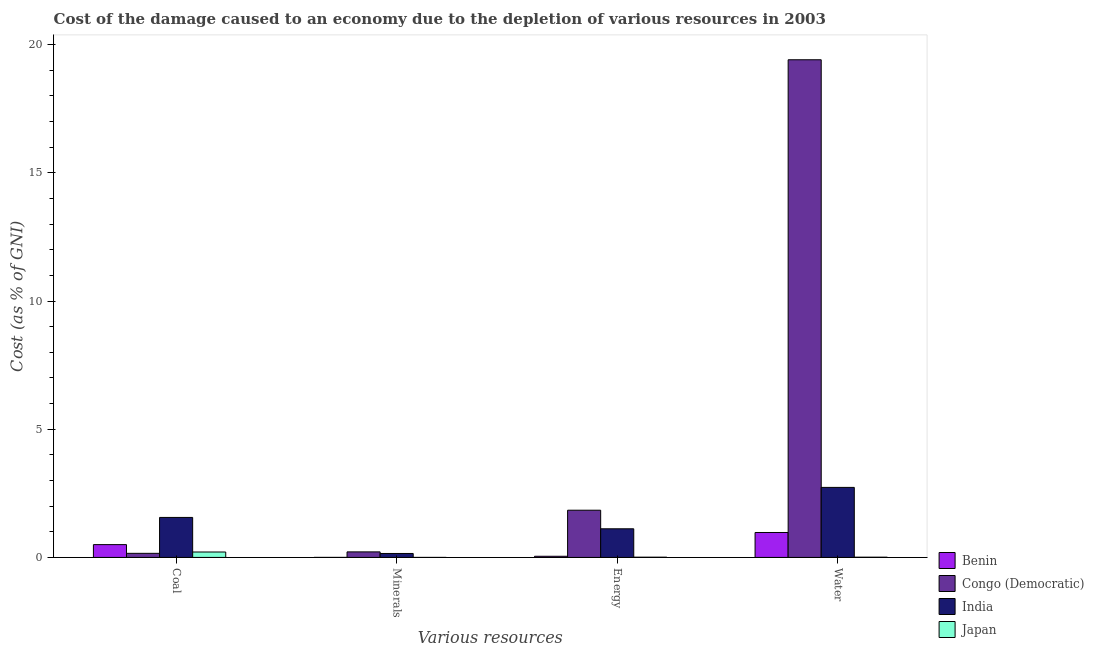How many groups of bars are there?
Ensure brevity in your answer.  4. Are the number of bars per tick equal to the number of legend labels?
Make the answer very short. Yes. Are the number of bars on each tick of the X-axis equal?
Ensure brevity in your answer.  Yes. What is the label of the 3rd group of bars from the left?
Provide a succinct answer. Energy. What is the cost of damage due to depletion of water in India?
Give a very brief answer. 2.73. Across all countries, what is the maximum cost of damage due to depletion of water?
Your answer should be compact. 19.41. Across all countries, what is the minimum cost of damage due to depletion of coal?
Make the answer very short. 0.16. In which country was the cost of damage due to depletion of minerals minimum?
Your response must be concise. Japan. What is the total cost of damage due to depletion of minerals in the graph?
Offer a very short reply. 0.37. What is the difference between the cost of damage due to depletion of coal in Benin and that in Japan?
Offer a very short reply. 0.29. What is the difference between the cost of damage due to depletion of minerals in Benin and the cost of damage due to depletion of water in Congo (Democratic)?
Make the answer very short. -19.41. What is the average cost of damage due to depletion of minerals per country?
Your response must be concise. 0.09. What is the difference between the cost of damage due to depletion of coal and cost of damage due to depletion of energy in Japan?
Keep it short and to the point. 0.2. What is the ratio of the cost of damage due to depletion of coal in India to that in Japan?
Your answer should be compact. 7.38. Is the difference between the cost of damage due to depletion of coal in Benin and Congo (Democratic) greater than the difference between the cost of damage due to depletion of minerals in Benin and Congo (Democratic)?
Make the answer very short. Yes. What is the difference between the highest and the second highest cost of damage due to depletion of coal?
Your answer should be compact. 1.06. What is the difference between the highest and the lowest cost of damage due to depletion of water?
Provide a succinct answer. 19.4. What does the 2nd bar from the left in Coal represents?
Provide a succinct answer. Congo (Democratic). What does the 4th bar from the right in Water represents?
Your answer should be compact. Benin. Are all the bars in the graph horizontal?
Ensure brevity in your answer.  No. What is the difference between two consecutive major ticks on the Y-axis?
Your answer should be very brief. 5. Where does the legend appear in the graph?
Provide a short and direct response. Bottom right. How many legend labels are there?
Offer a very short reply. 4. How are the legend labels stacked?
Ensure brevity in your answer.  Vertical. What is the title of the graph?
Your response must be concise. Cost of the damage caused to an economy due to the depletion of various resources in 2003 . Does "Norway" appear as one of the legend labels in the graph?
Provide a short and direct response. No. What is the label or title of the X-axis?
Offer a terse response. Various resources. What is the label or title of the Y-axis?
Ensure brevity in your answer.  Cost (as % of GNI). What is the Cost (as % of GNI) of Benin in Coal?
Your answer should be compact. 0.5. What is the Cost (as % of GNI) of Congo (Democratic) in Coal?
Give a very brief answer. 0.16. What is the Cost (as % of GNI) of India in Coal?
Offer a terse response. 1.56. What is the Cost (as % of GNI) of Japan in Coal?
Provide a succinct answer. 0.21. What is the Cost (as % of GNI) in Benin in Minerals?
Provide a short and direct response. 0. What is the Cost (as % of GNI) in Congo (Democratic) in Minerals?
Offer a terse response. 0.22. What is the Cost (as % of GNI) in India in Minerals?
Your answer should be very brief. 0.15. What is the Cost (as % of GNI) of Japan in Minerals?
Your answer should be very brief. 0. What is the Cost (as % of GNI) of Benin in Energy?
Give a very brief answer. 0.04. What is the Cost (as % of GNI) of Congo (Democratic) in Energy?
Give a very brief answer. 1.84. What is the Cost (as % of GNI) in India in Energy?
Your response must be concise. 1.12. What is the Cost (as % of GNI) in Japan in Energy?
Your answer should be compact. 0.01. What is the Cost (as % of GNI) in Benin in Water?
Ensure brevity in your answer.  0.97. What is the Cost (as % of GNI) in Congo (Democratic) in Water?
Provide a succinct answer. 19.41. What is the Cost (as % of GNI) of India in Water?
Give a very brief answer. 2.73. What is the Cost (as % of GNI) of Japan in Water?
Ensure brevity in your answer.  0.01. Across all Various resources, what is the maximum Cost (as % of GNI) in Benin?
Offer a terse response. 0.97. Across all Various resources, what is the maximum Cost (as % of GNI) of Congo (Democratic)?
Your answer should be compact. 19.41. Across all Various resources, what is the maximum Cost (as % of GNI) in India?
Offer a very short reply. 2.73. Across all Various resources, what is the maximum Cost (as % of GNI) of Japan?
Ensure brevity in your answer.  0.21. Across all Various resources, what is the minimum Cost (as % of GNI) of Benin?
Ensure brevity in your answer.  0. Across all Various resources, what is the minimum Cost (as % of GNI) of Congo (Democratic)?
Ensure brevity in your answer.  0.16. Across all Various resources, what is the minimum Cost (as % of GNI) of India?
Give a very brief answer. 0.15. Across all Various resources, what is the minimum Cost (as % of GNI) of Japan?
Keep it short and to the point. 0. What is the total Cost (as % of GNI) of Benin in the graph?
Provide a succinct answer. 1.52. What is the total Cost (as % of GNI) of Congo (Democratic) in the graph?
Keep it short and to the point. 21.63. What is the total Cost (as % of GNI) in India in the graph?
Offer a terse response. 5.56. What is the total Cost (as % of GNI) of Japan in the graph?
Your answer should be compact. 0.23. What is the difference between the Cost (as % of GNI) in Benin in Coal and that in Minerals?
Keep it short and to the point. 0.5. What is the difference between the Cost (as % of GNI) in Congo (Democratic) in Coal and that in Minerals?
Provide a succinct answer. -0.06. What is the difference between the Cost (as % of GNI) of India in Coal and that in Minerals?
Ensure brevity in your answer.  1.41. What is the difference between the Cost (as % of GNI) in Japan in Coal and that in Minerals?
Keep it short and to the point. 0.21. What is the difference between the Cost (as % of GNI) of Benin in Coal and that in Energy?
Provide a succinct answer. 0.46. What is the difference between the Cost (as % of GNI) in Congo (Democratic) in Coal and that in Energy?
Your answer should be very brief. -1.68. What is the difference between the Cost (as % of GNI) in India in Coal and that in Energy?
Your answer should be compact. 0.44. What is the difference between the Cost (as % of GNI) in Japan in Coal and that in Energy?
Your answer should be compact. 0.2. What is the difference between the Cost (as % of GNI) of Benin in Coal and that in Water?
Your response must be concise. -0.47. What is the difference between the Cost (as % of GNI) of Congo (Democratic) in Coal and that in Water?
Your answer should be very brief. -19.25. What is the difference between the Cost (as % of GNI) of India in Coal and that in Water?
Offer a very short reply. -1.17. What is the difference between the Cost (as % of GNI) in Japan in Coal and that in Water?
Your answer should be compact. 0.2. What is the difference between the Cost (as % of GNI) in Benin in Minerals and that in Energy?
Ensure brevity in your answer.  -0.04. What is the difference between the Cost (as % of GNI) of Congo (Democratic) in Minerals and that in Energy?
Make the answer very short. -1.63. What is the difference between the Cost (as % of GNI) in India in Minerals and that in Energy?
Provide a succinct answer. -0.96. What is the difference between the Cost (as % of GNI) of Japan in Minerals and that in Energy?
Give a very brief answer. -0.01. What is the difference between the Cost (as % of GNI) in Benin in Minerals and that in Water?
Give a very brief answer. -0.97. What is the difference between the Cost (as % of GNI) in Congo (Democratic) in Minerals and that in Water?
Keep it short and to the point. -19.19. What is the difference between the Cost (as % of GNI) of India in Minerals and that in Water?
Your response must be concise. -2.58. What is the difference between the Cost (as % of GNI) of Japan in Minerals and that in Water?
Offer a terse response. -0.01. What is the difference between the Cost (as % of GNI) in Benin in Energy and that in Water?
Provide a short and direct response. -0.93. What is the difference between the Cost (as % of GNI) in Congo (Democratic) in Energy and that in Water?
Offer a very short reply. -17.57. What is the difference between the Cost (as % of GNI) in India in Energy and that in Water?
Your answer should be compact. -1.61. What is the difference between the Cost (as % of GNI) in Japan in Energy and that in Water?
Make the answer very short. -0. What is the difference between the Cost (as % of GNI) of Benin in Coal and the Cost (as % of GNI) of Congo (Democratic) in Minerals?
Your answer should be compact. 0.28. What is the difference between the Cost (as % of GNI) of Benin in Coal and the Cost (as % of GNI) of India in Minerals?
Offer a terse response. 0.35. What is the difference between the Cost (as % of GNI) of Benin in Coal and the Cost (as % of GNI) of Japan in Minerals?
Offer a very short reply. 0.5. What is the difference between the Cost (as % of GNI) in Congo (Democratic) in Coal and the Cost (as % of GNI) in India in Minerals?
Provide a short and direct response. 0.01. What is the difference between the Cost (as % of GNI) in Congo (Democratic) in Coal and the Cost (as % of GNI) in Japan in Minerals?
Provide a short and direct response. 0.16. What is the difference between the Cost (as % of GNI) in India in Coal and the Cost (as % of GNI) in Japan in Minerals?
Make the answer very short. 1.56. What is the difference between the Cost (as % of GNI) of Benin in Coal and the Cost (as % of GNI) of Congo (Democratic) in Energy?
Offer a terse response. -1.34. What is the difference between the Cost (as % of GNI) in Benin in Coal and the Cost (as % of GNI) in India in Energy?
Provide a short and direct response. -0.62. What is the difference between the Cost (as % of GNI) of Benin in Coal and the Cost (as % of GNI) of Japan in Energy?
Make the answer very short. 0.49. What is the difference between the Cost (as % of GNI) in Congo (Democratic) in Coal and the Cost (as % of GNI) in India in Energy?
Offer a terse response. -0.96. What is the difference between the Cost (as % of GNI) in Congo (Democratic) in Coal and the Cost (as % of GNI) in Japan in Energy?
Provide a succinct answer. 0.15. What is the difference between the Cost (as % of GNI) in India in Coal and the Cost (as % of GNI) in Japan in Energy?
Provide a succinct answer. 1.55. What is the difference between the Cost (as % of GNI) of Benin in Coal and the Cost (as % of GNI) of Congo (Democratic) in Water?
Provide a short and direct response. -18.91. What is the difference between the Cost (as % of GNI) in Benin in Coal and the Cost (as % of GNI) in India in Water?
Provide a succinct answer. -2.23. What is the difference between the Cost (as % of GNI) of Benin in Coal and the Cost (as % of GNI) of Japan in Water?
Provide a succinct answer. 0.49. What is the difference between the Cost (as % of GNI) in Congo (Democratic) in Coal and the Cost (as % of GNI) in India in Water?
Provide a succinct answer. -2.57. What is the difference between the Cost (as % of GNI) in Congo (Democratic) in Coal and the Cost (as % of GNI) in Japan in Water?
Provide a succinct answer. 0.15. What is the difference between the Cost (as % of GNI) in India in Coal and the Cost (as % of GNI) in Japan in Water?
Your answer should be very brief. 1.55. What is the difference between the Cost (as % of GNI) in Benin in Minerals and the Cost (as % of GNI) in Congo (Democratic) in Energy?
Offer a very short reply. -1.84. What is the difference between the Cost (as % of GNI) in Benin in Minerals and the Cost (as % of GNI) in India in Energy?
Offer a terse response. -1.12. What is the difference between the Cost (as % of GNI) of Benin in Minerals and the Cost (as % of GNI) of Japan in Energy?
Keep it short and to the point. -0.01. What is the difference between the Cost (as % of GNI) of Congo (Democratic) in Minerals and the Cost (as % of GNI) of India in Energy?
Make the answer very short. -0.9. What is the difference between the Cost (as % of GNI) in Congo (Democratic) in Minerals and the Cost (as % of GNI) in Japan in Energy?
Offer a very short reply. 0.21. What is the difference between the Cost (as % of GNI) of India in Minerals and the Cost (as % of GNI) of Japan in Energy?
Give a very brief answer. 0.15. What is the difference between the Cost (as % of GNI) in Benin in Minerals and the Cost (as % of GNI) in Congo (Democratic) in Water?
Keep it short and to the point. -19.41. What is the difference between the Cost (as % of GNI) of Benin in Minerals and the Cost (as % of GNI) of India in Water?
Offer a terse response. -2.73. What is the difference between the Cost (as % of GNI) in Benin in Minerals and the Cost (as % of GNI) in Japan in Water?
Ensure brevity in your answer.  -0.01. What is the difference between the Cost (as % of GNI) in Congo (Democratic) in Minerals and the Cost (as % of GNI) in India in Water?
Provide a succinct answer. -2.51. What is the difference between the Cost (as % of GNI) in Congo (Democratic) in Minerals and the Cost (as % of GNI) in Japan in Water?
Keep it short and to the point. 0.21. What is the difference between the Cost (as % of GNI) of India in Minerals and the Cost (as % of GNI) of Japan in Water?
Your answer should be very brief. 0.14. What is the difference between the Cost (as % of GNI) of Benin in Energy and the Cost (as % of GNI) of Congo (Democratic) in Water?
Keep it short and to the point. -19.37. What is the difference between the Cost (as % of GNI) of Benin in Energy and the Cost (as % of GNI) of India in Water?
Offer a terse response. -2.69. What is the difference between the Cost (as % of GNI) of Benin in Energy and the Cost (as % of GNI) of Japan in Water?
Give a very brief answer. 0.04. What is the difference between the Cost (as % of GNI) in Congo (Democratic) in Energy and the Cost (as % of GNI) in India in Water?
Provide a short and direct response. -0.89. What is the difference between the Cost (as % of GNI) of Congo (Democratic) in Energy and the Cost (as % of GNI) of Japan in Water?
Your response must be concise. 1.83. What is the difference between the Cost (as % of GNI) of India in Energy and the Cost (as % of GNI) of Japan in Water?
Offer a very short reply. 1.11. What is the average Cost (as % of GNI) in Benin per Various resources?
Your answer should be compact. 0.38. What is the average Cost (as % of GNI) of Congo (Democratic) per Various resources?
Provide a succinct answer. 5.41. What is the average Cost (as % of GNI) in India per Various resources?
Your response must be concise. 1.39. What is the average Cost (as % of GNI) in Japan per Various resources?
Provide a succinct answer. 0.06. What is the difference between the Cost (as % of GNI) of Benin and Cost (as % of GNI) of Congo (Democratic) in Coal?
Offer a very short reply. 0.34. What is the difference between the Cost (as % of GNI) of Benin and Cost (as % of GNI) of India in Coal?
Provide a succinct answer. -1.06. What is the difference between the Cost (as % of GNI) in Benin and Cost (as % of GNI) in Japan in Coal?
Your response must be concise. 0.29. What is the difference between the Cost (as % of GNI) of Congo (Democratic) and Cost (as % of GNI) of India in Coal?
Offer a very short reply. -1.4. What is the difference between the Cost (as % of GNI) of Congo (Democratic) and Cost (as % of GNI) of Japan in Coal?
Your response must be concise. -0.05. What is the difference between the Cost (as % of GNI) in India and Cost (as % of GNI) in Japan in Coal?
Keep it short and to the point. 1.35. What is the difference between the Cost (as % of GNI) in Benin and Cost (as % of GNI) in Congo (Democratic) in Minerals?
Offer a terse response. -0.22. What is the difference between the Cost (as % of GNI) of Benin and Cost (as % of GNI) of India in Minerals?
Your response must be concise. -0.15. What is the difference between the Cost (as % of GNI) in Benin and Cost (as % of GNI) in Japan in Minerals?
Your answer should be very brief. 0. What is the difference between the Cost (as % of GNI) in Congo (Democratic) and Cost (as % of GNI) in India in Minerals?
Your response must be concise. 0.06. What is the difference between the Cost (as % of GNI) in Congo (Democratic) and Cost (as % of GNI) in Japan in Minerals?
Give a very brief answer. 0.22. What is the difference between the Cost (as % of GNI) of India and Cost (as % of GNI) of Japan in Minerals?
Your response must be concise. 0.15. What is the difference between the Cost (as % of GNI) in Benin and Cost (as % of GNI) in Congo (Democratic) in Energy?
Give a very brief answer. -1.8. What is the difference between the Cost (as % of GNI) in Benin and Cost (as % of GNI) in India in Energy?
Keep it short and to the point. -1.07. What is the difference between the Cost (as % of GNI) of Benin and Cost (as % of GNI) of Japan in Energy?
Offer a terse response. 0.04. What is the difference between the Cost (as % of GNI) of Congo (Democratic) and Cost (as % of GNI) of India in Energy?
Your answer should be very brief. 0.72. What is the difference between the Cost (as % of GNI) in Congo (Democratic) and Cost (as % of GNI) in Japan in Energy?
Your answer should be very brief. 1.83. What is the difference between the Cost (as % of GNI) in India and Cost (as % of GNI) in Japan in Energy?
Offer a very short reply. 1.11. What is the difference between the Cost (as % of GNI) in Benin and Cost (as % of GNI) in Congo (Democratic) in Water?
Make the answer very short. -18.44. What is the difference between the Cost (as % of GNI) in Benin and Cost (as % of GNI) in India in Water?
Make the answer very short. -1.76. What is the difference between the Cost (as % of GNI) of Benin and Cost (as % of GNI) of Japan in Water?
Provide a succinct answer. 0.96. What is the difference between the Cost (as % of GNI) in Congo (Democratic) and Cost (as % of GNI) in India in Water?
Offer a terse response. 16.68. What is the difference between the Cost (as % of GNI) of Congo (Democratic) and Cost (as % of GNI) of Japan in Water?
Your answer should be compact. 19.4. What is the difference between the Cost (as % of GNI) in India and Cost (as % of GNI) in Japan in Water?
Ensure brevity in your answer.  2.72. What is the ratio of the Cost (as % of GNI) in Benin in Coal to that in Minerals?
Your response must be concise. 448.63. What is the ratio of the Cost (as % of GNI) in Congo (Democratic) in Coal to that in Minerals?
Provide a short and direct response. 0.74. What is the ratio of the Cost (as % of GNI) of India in Coal to that in Minerals?
Offer a terse response. 10.14. What is the ratio of the Cost (as % of GNI) in Japan in Coal to that in Minerals?
Offer a very short reply. 831.3. What is the ratio of the Cost (as % of GNI) in Benin in Coal to that in Energy?
Offer a very short reply. 11.18. What is the ratio of the Cost (as % of GNI) of Congo (Democratic) in Coal to that in Energy?
Offer a terse response. 0.09. What is the ratio of the Cost (as % of GNI) of India in Coal to that in Energy?
Provide a succinct answer. 1.4. What is the ratio of the Cost (as % of GNI) in Japan in Coal to that in Energy?
Offer a terse response. 24.01. What is the ratio of the Cost (as % of GNI) in Benin in Coal to that in Water?
Your response must be concise. 0.51. What is the ratio of the Cost (as % of GNI) in Congo (Democratic) in Coal to that in Water?
Your answer should be compact. 0.01. What is the ratio of the Cost (as % of GNI) of India in Coal to that in Water?
Make the answer very short. 0.57. What is the ratio of the Cost (as % of GNI) of Japan in Coal to that in Water?
Offer a terse response. 23.33. What is the ratio of the Cost (as % of GNI) in Benin in Minerals to that in Energy?
Your answer should be compact. 0.02. What is the ratio of the Cost (as % of GNI) in Congo (Democratic) in Minerals to that in Energy?
Your answer should be compact. 0.12. What is the ratio of the Cost (as % of GNI) of India in Minerals to that in Energy?
Keep it short and to the point. 0.14. What is the ratio of the Cost (as % of GNI) in Japan in Minerals to that in Energy?
Your answer should be very brief. 0.03. What is the ratio of the Cost (as % of GNI) of Benin in Minerals to that in Water?
Keep it short and to the point. 0. What is the ratio of the Cost (as % of GNI) in Congo (Democratic) in Minerals to that in Water?
Offer a terse response. 0.01. What is the ratio of the Cost (as % of GNI) of India in Minerals to that in Water?
Keep it short and to the point. 0.06. What is the ratio of the Cost (as % of GNI) in Japan in Minerals to that in Water?
Your response must be concise. 0.03. What is the ratio of the Cost (as % of GNI) of Benin in Energy to that in Water?
Provide a succinct answer. 0.05. What is the ratio of the Cost (as % of GNI) in Congo (Democratic) in Energy to that in Water?
Give a very brief answer. 0.09. What is the ratio of the Cost (as % of GNI) of India in Energy to that in Water?
Give a very brief answer. 0.41. What is the ratio of the Cost (as % of GNI) in Japan in Energy to that in Water?
Give a very brief answer. 0.97. What is the difference between the highest and the second highest Cost (as % of GNI) of Benin?
Offer a very short reply. 0.47. What is the difference between the highest and the second highest Cost (as % of GNI) in Congo (Democratic)?
Your response must be concise. 17.57. What is the difference between the highest and the second highest Cost (as % of GNI) in India?
Keep it short and to the point. 1.17. What is the difference between the highest and the second highest Cost (as % of GNI) in Japan?
Your answer should be very brief. 0.2. What is the difference between the highest and the lowest Cost (as % of GNI) in Benin?
Your response must be concise. 0.97. What is the difference between the highest and the lowest Cost (as % of GNI) in Congo (Democratic)?
Give a very brief answer. 19.25. What is the difference between the highest and the lowest Cost (as % of GNI) of India?
Your answer should be very brief. 2.58. What is the difference between the highest and the lowest Cost (as % of GNI) of Japan?
Your answer should be compact. 0.21. 